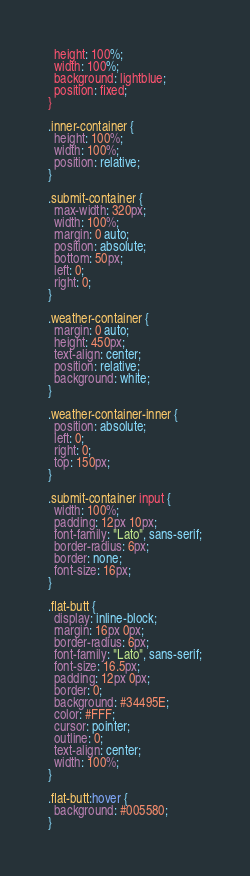<code> <loc_0><loc_0><loc_500><loc_500><_CSS_>  height: 100%;
  width: 100%;
  background: lightblue;
  position: fixed;
}

.inner-container {
  height: 100%;
  width: 100%;
  position: relative;
}

.submit-container {
  max-width: 320px;
  width: 100%;
  margin: 0 auto;
  position: absolute;
  bottom: 50px;
  left: 0;
  right: 0;
}

.weather-container {
  margin: 0 auto;
  height: 450px;
  text-align: center;
  position: relative;
  background: white;
}

.weather-container-inner {
  position: absolute;
  left: 0;
  right: 0;
  top: 150px;
}

.submit-container input {
  width: 100%;
  padding: 12px 10px;
  font-family: "Lato", sans-serif;
  border-radius: 6px;
  border: none;
  font-size: 16px;
}

.flat-butt {
  display: inline-block;
  margin: 16px 0px;
  border-radius: 6px;
  font-family: "Lato", sans-serif;
  font-size: 16.5px;
  padding: 12px 0px;
  border: 0;
  background: #34495E;
  color: #FFF;
  cursor: pointer;
  outline: 0;
  text-align: center;
  width: 100%;
}

.flat-butt:hover {
  background: #005580;
}

</code> 